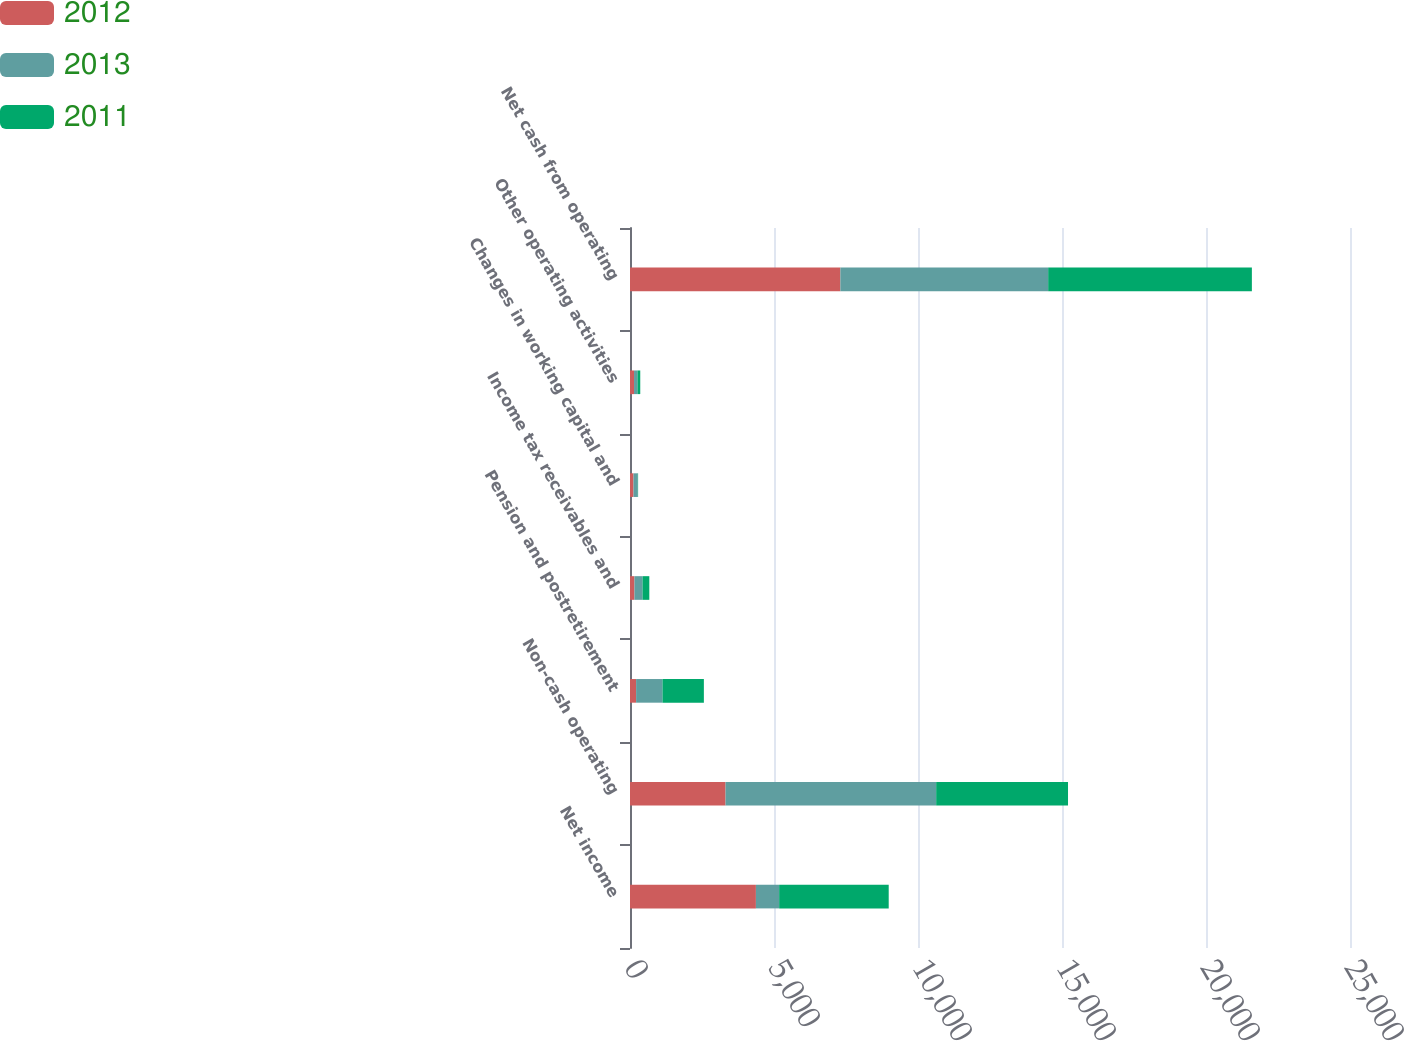<chart> <loc_0><loc_0><loc_500><loc_500><stacked_bar_chart><ecel><fcel>Net income<fcel>Non-cash operating<fcel>Pension and postretirement<fcel>Income tax receivables and<fcel>Changes in working capital and<fcel>Other operating activities<fcel>Net cash from operating<nl><fcel>2012<fcel>4372<fcel>3318<fcel>212<fcel>155<fcel>121<fcel>140<fcel>7304<nl><fcel>2013<fcel>807<fcel>7313<fcel>917<fcel>280<fcel>148<fcel>119<fcel>7216<nl><fcel>2011<fcel>3804<fcel>4578<fcel>1436<fcel>236<fcel>12<fcel>97<fcel>7073<nl></chart> 